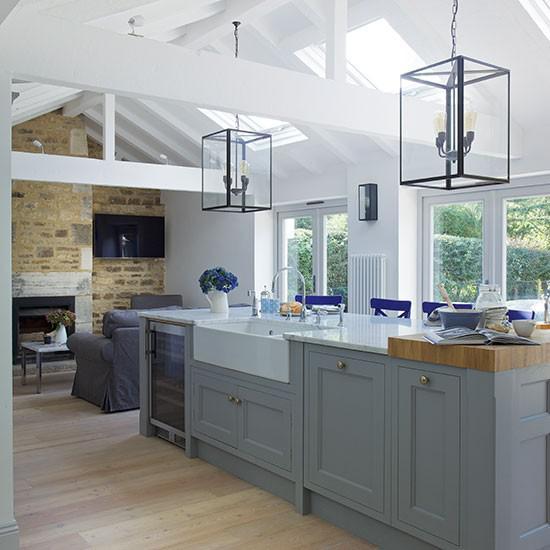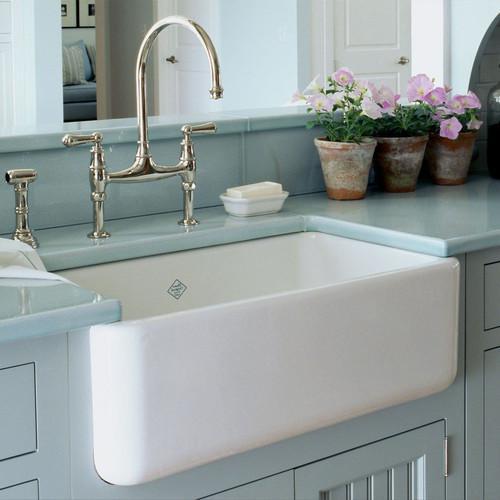The first image is the image on the left, the second image is the image on the right. For the images displayed, is the sentence "In one image, a bathroom vanity has two matching white sinks." factually correct? Answer yes or no. No. The first image is the image on the left, the second image is the image on the right. Analyze the images presented: Is the assertion "In 1 of the images, 1 sink has a window behind it." valid? Answer yes or no. Yes. 